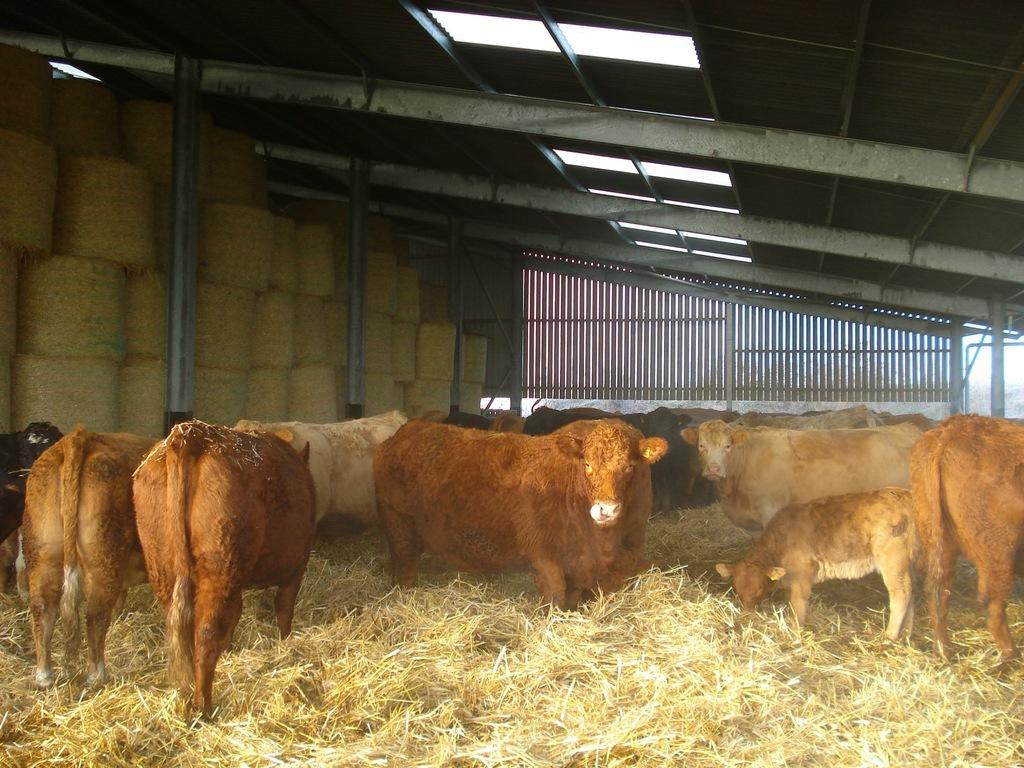What can be found under the shed in the image? There are animals under the shed in the image. What is located at the back of the image? There is a railing at the back of the image. What is visible at the top of the image? There are lights at the top of the image. What type of vegetation is at the bottom of the image? There is grass at the bottom of the image. Who is the owner of the animals in the image? There is no information provided about the owner of the animals in the image. How many toes does the manager have in the image? There is no manager or any reference to toes in the image. 